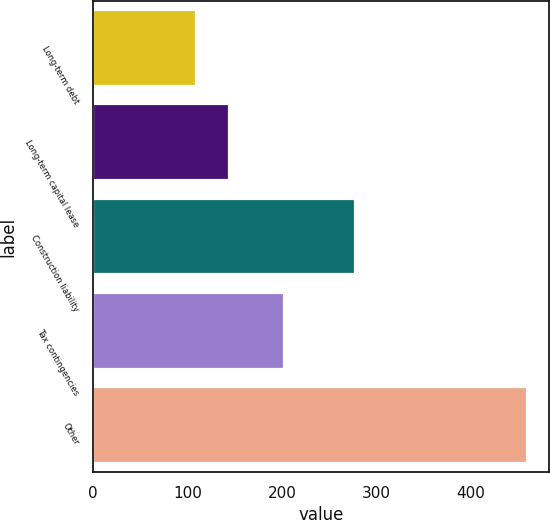Convert chart to OTSL. <chart><loc_0><loc_0><loc_500><loc_500><bar_chart><fcel>Long-term debt<fcel>Long-term capital lease<fcel>Construction liability<fcel>Tax contingencies<fcel>Other<nl><fcel>109<fcel>144.1<fcel>278<fcel>202<fcel>460<nl></chart> 